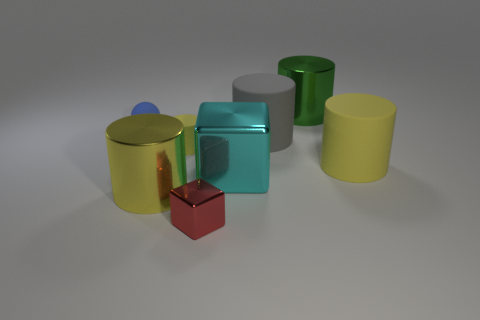What shape is the rubber thing that is both behind the tiny cylinder and on the left side of the small red thing?
Provide a succinct answer. Sphere. What material is the yellow cylinder that is to the left of the matte cylinder that is to the left of the cyan metallic cube?
Your answer should be compact. Metal. Do the big object that is on the left side of the tiny cube and the big green thing have the same material?
Make the answer very short. Yes. How big is the metallic cylinder behind the tiny blue matte ball?
Provide a short and direct response. Large. Are there any tiny red objects behind the metallic thing behind the gray object?
Your response must be concise. No. There is a rubber object that is right of the gray matte cylinder; does it have the same color as the large matte cylinder behind the large yellow matte thing?
Ensure brevity in your answer.  No. What color is the tiny cylinder?
Your response must be concise. Yellow. Are there any other things of the same color as the rubber ball?
Your response must be concise. No. The tiny thing that is both behind the big block and in front of the tiny blue rubber object is what color?
Your answer should be very brief. Yellow. There is a shiny cylinder that is behind the blue thing; does it have the same size as the small rubber cylinder?
Give a very brief answer. No. 